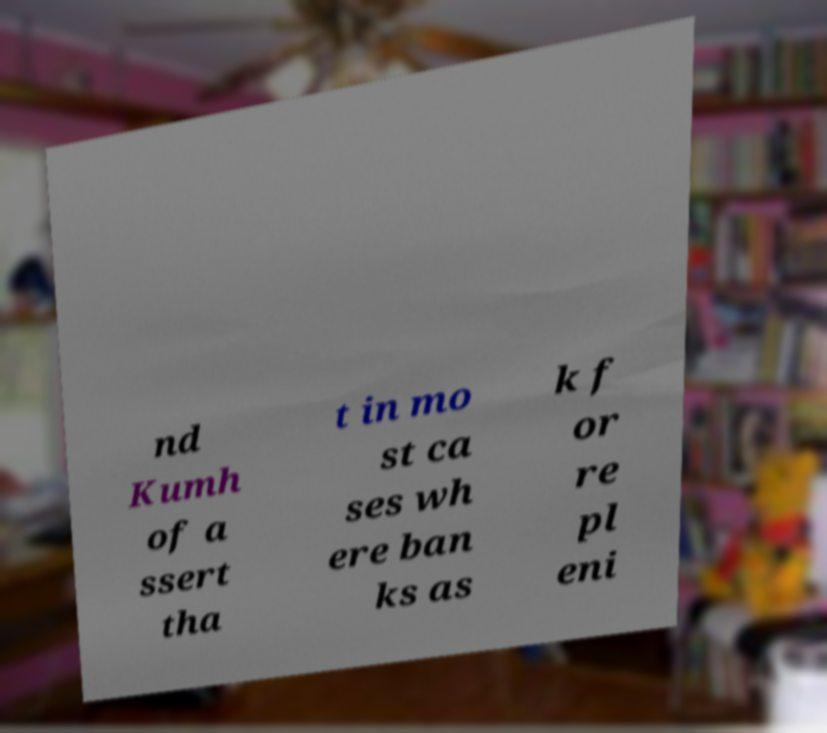Could you extract and type out the text from this image? nd Kumh of a ssert tha t in mo st ca ses wh ere ban ks as k f or re pl eni 